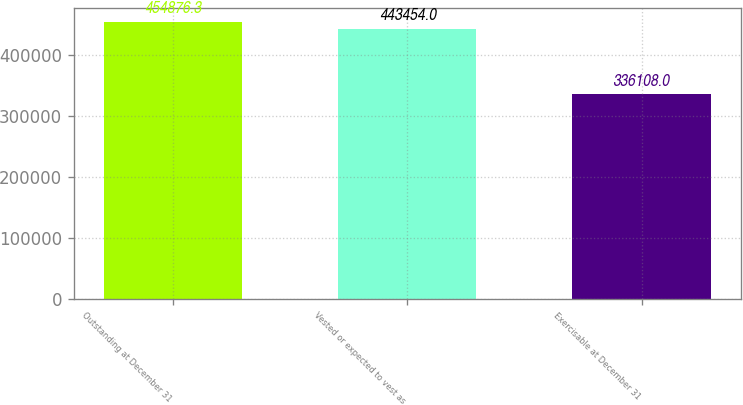Convert chart to OTSL. <chart><loc_0><loc_0><loc_500><loc_500><bar_chart><fcel>Outstanding at December 31<fcel>Vested or expected to vest as<fcel>Exercisable at December 31<nl><fcel>454876<fcel>443454<fcel>336108<nl></chart> 